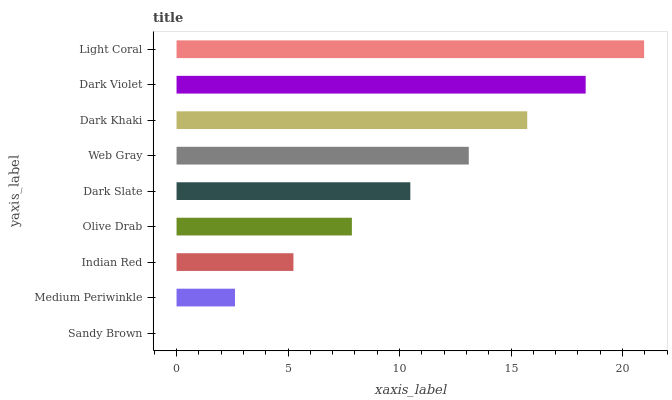Is Sandy Brown the minimum?
Answer yes or no. Yes. Is Light Coral the maximum?
Answer yes or no. Yes. Is Medium Periwinkle the minimum?
Answer yes or no. No. Is Medium Periwinkle the maximum?
Answer yes or no. No. Is Medium Periwinkle greater than Sandy Brown?
Answer yes or no. Yes. Is Sandy Brown less than Medium Periwinkle?
Answer yes or no. Yes. Is Sandy Brown greater than Medium Periwinkle?
Answer yes or no. No. Is Medium Periwinkle less than Sandy Brown?
Answer yes or no. No. Is Dark Slate the high median?
Answer yes or no. Yes. Is Dark Slate the low median?
Answer yes or no. Yes. Is Indian Red the high median?
Answer yes or no. No. Is Indian Red the low median?
Answer yes or no. No. 